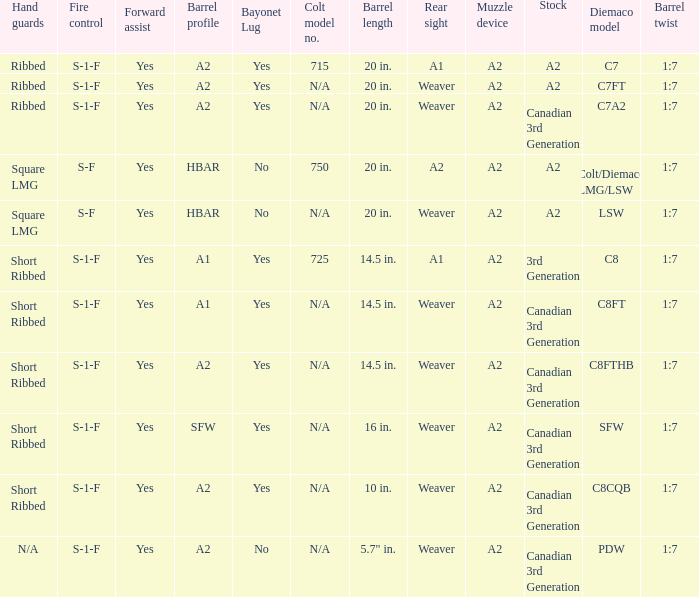Which Barrel twist has a Stock of canadian 3rd generation and a Hand guards of short ribbed? 1:7, 1:7, 1:7, 1:7. 